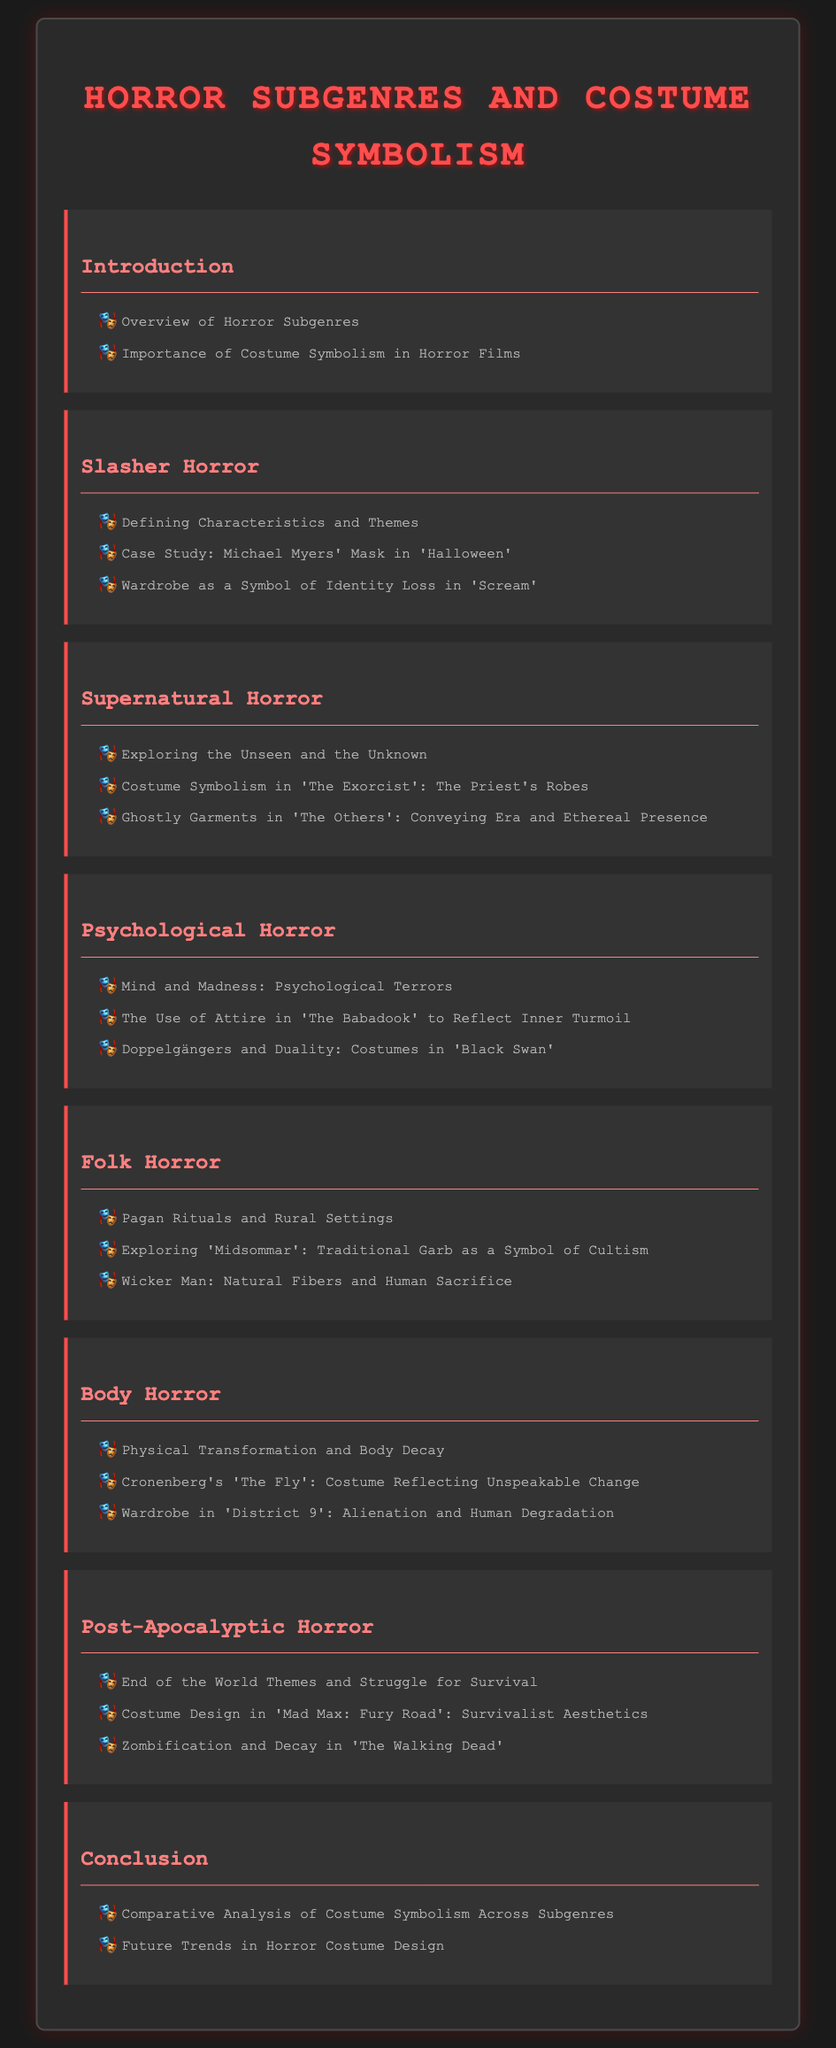What are the two main topics discussed in the Introduction? The Introduction covers an overview of horror subgenres and the importance of costume symbolism in horror films.
Answer: Overview of Horror Subgenres, Importance of Costume Symbolism Which horror subgenre features Michael Myers' Mask? This detail can be found in the analysis of slasher horror, specifically referencing 'Halloween'.
Answer: Slasher Horror What symbol is used to represent identity loss in 'Scream'? The document mentions that the wardrobe symbolizes identity loss in the film 'Scream'.
Answer: Wardrobe In which film are the priest's robes a significant element? The use of priest's robes in a supernatural context is highlighted in 'The Exorcist'.
Answer: The Exorcist What is the focus of body horror? The document mentions that the focus is on physical transformation and body decay.
Answer: Physical Transformation and Body Decay How is costume design used in 'Mad Max: Fury Road'? The section discusses survivalist aesthetics related to costume design in 'Mad Max: Fury Road'.
Answer: Survivalist Aesthetics What analysis is presented in the Conclusion? The conclusion compares costume symbolism across horror subgenres and discusses future trends in costume design.
Answer: Comparative Analysis of Costume Symbolism Across Subgenres Which subgenre explores traditional garb as a symbol of cultism? 'Midsommar' under the folk horror section examines traditional garb in this context.
Answer: Folk Horror What thematic concept does psychological horror deal with? The thematic concept dealt with in psychological horror is mind and madness.
Answer: Mind and Madness 